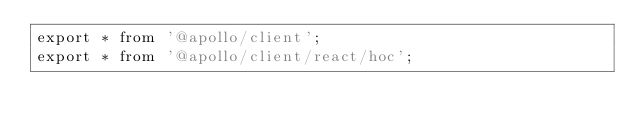<code> <loc_0><loc_0><loc_500><loc_500><_JavaScript_>export * from '@apollo/client';
export * from '@apollo/client/react/hoc';
</code> 